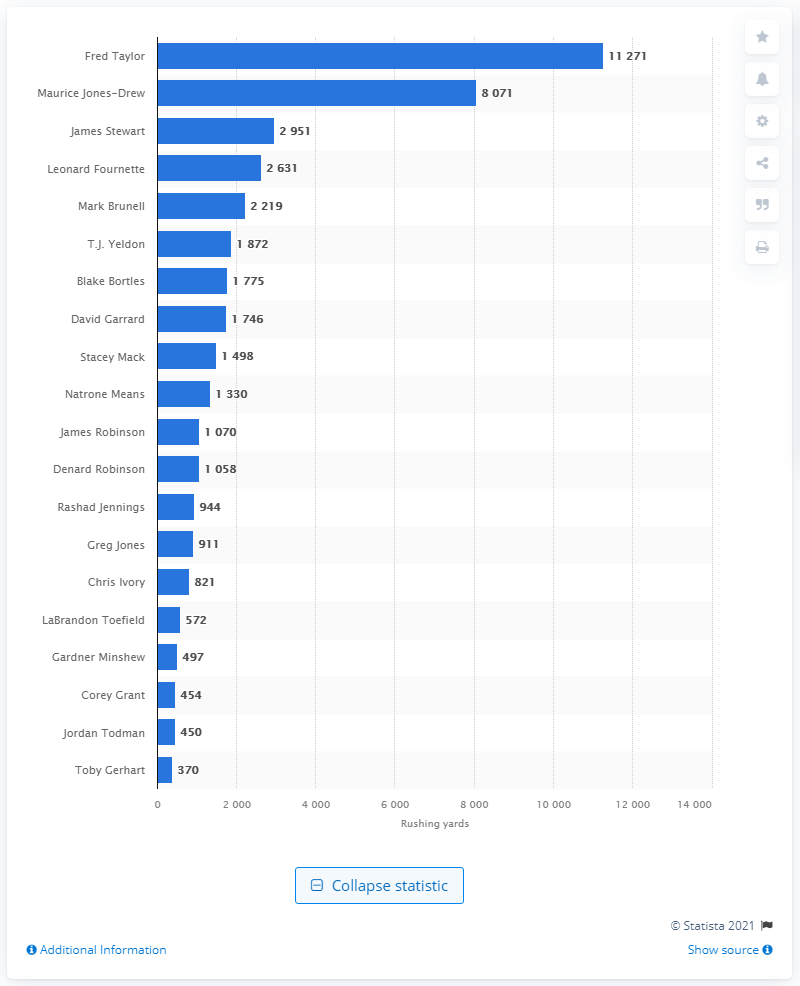Highlight a few significant elements in this photo. Fred Taylor is the career rushing leader of the Jacksonville Jaguars. 